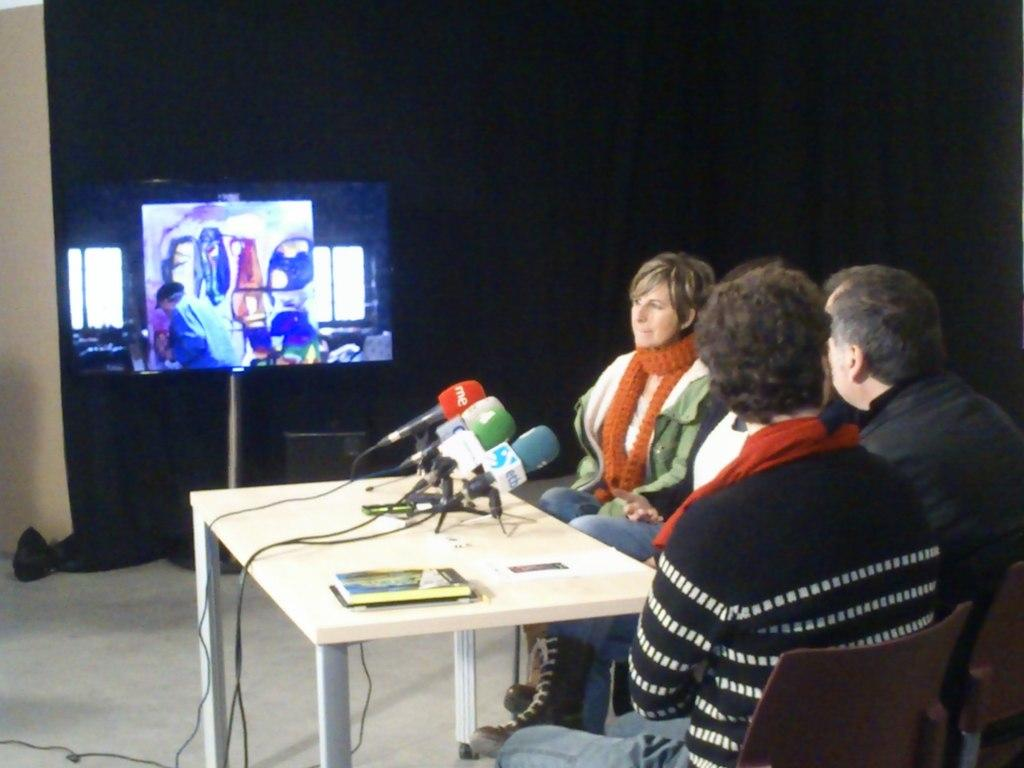How many people are sitting in the image? There are three people sitting on chairs in the image. What objects are on the table in the image? There are mics on a table in the image. What can be seen in the background of the image? There is a monitor in the background of the image. What type of fairies are flying around the people in the image? There are no fairies present in the image. What is the title of the event taking place in the image? The provided facts do not mention any event or title. 